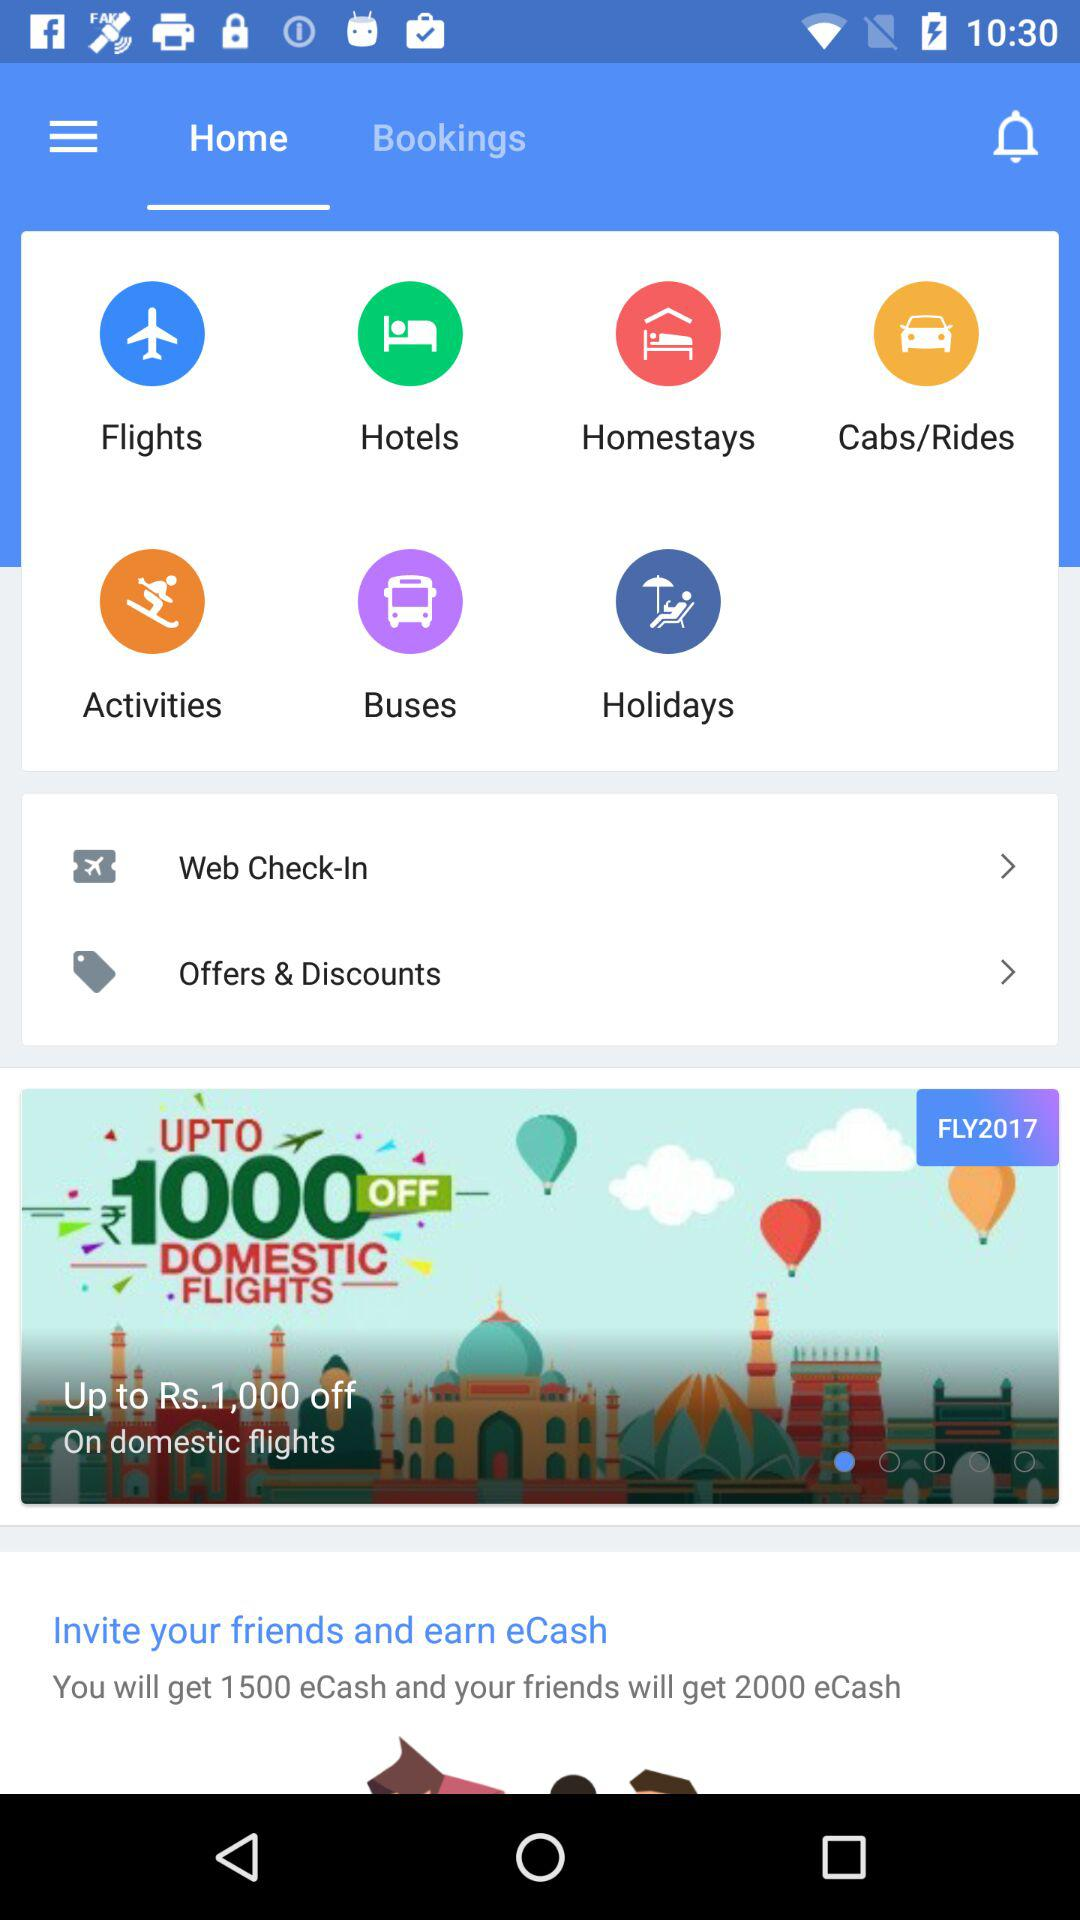How many more eCash will your friends get than you?
Answer the question using a single word or phrase. 500 